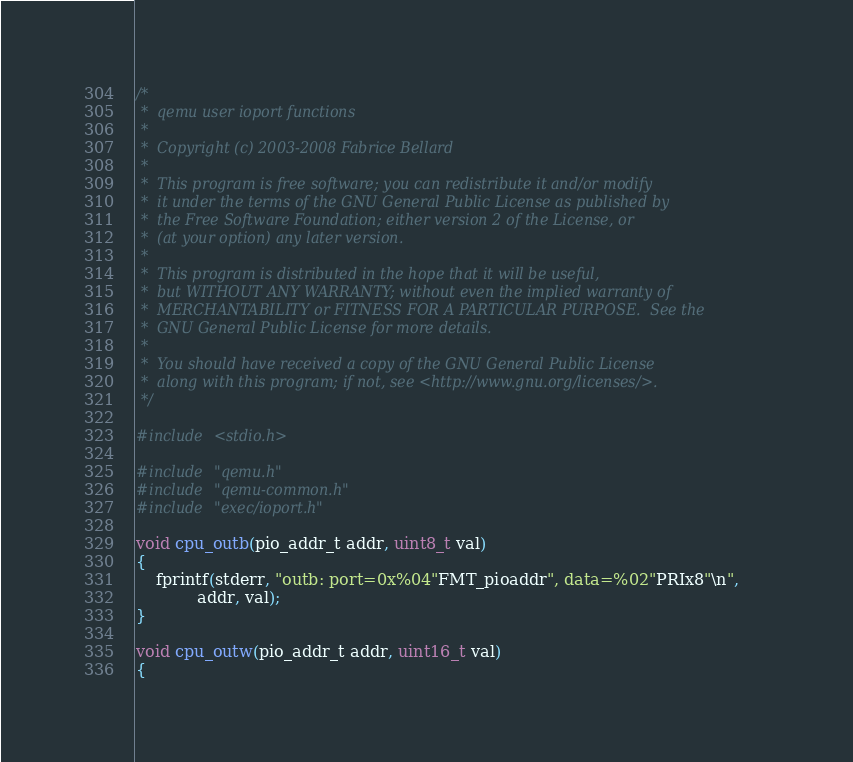<code> <loc_0><loc_0><loc_500><loc_500><_C_>/*
 *  qemu user ioport functions
 *
 *  Copyright (c) 2003-2008 Fabrice Bellard
 *
 *  This program is free software; you can redistribute it and/or modify
 *  it under the terms of the GNU General Public License as published by
 *  the Free Software Foundation; either version 2 of the License, or
 *  (at your option) any later version.
 *
 *  This program is distributed in the hope that it will be useful,
 *  but WITHOUT ANY WARRANTY; without even the implied warranty of
 *  MERCHANTABILITY or FITNESS FOR A PARTICULAR PURPOSE.  See the
 *  GNU General Public License for more details.
 *
 *  You should have received a copy of the GNU General Public License
 *  along with this program; if not, see <http://www.gnu.org/licenses/>.
 */

#include <stdio.h>

#include "qemu.h"
#include "qemu-common.h"
#include "exec/ioport.h"

void cpu_outb(pio_addr_t addr, uint8_t val)
{
    fprintf(stderr, "outb: port=0x%04"FMT_pioaddr", data=%02"PRIx8"\n",
            addr, val);
}

void cpu_outw(pio_addr_t addr, uint16_t val)
{</code> 